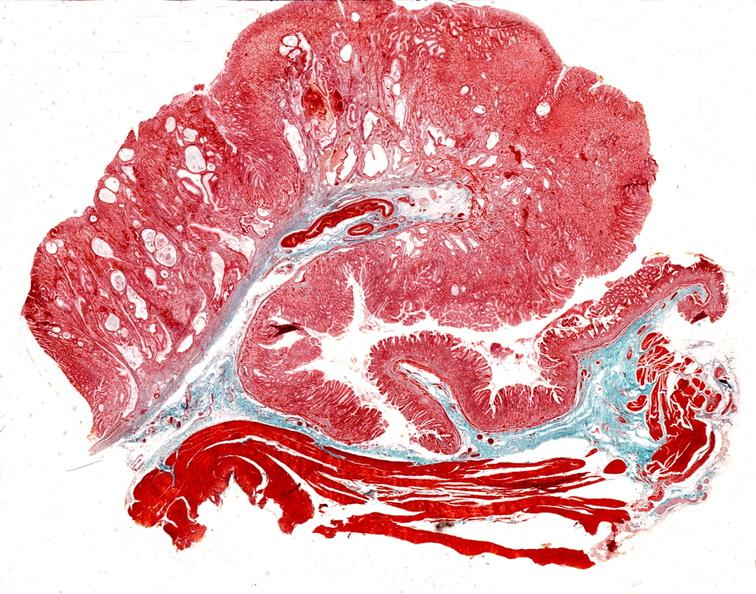does iron show stomach, giant rugose hyperplasia?
Answer the question using a single word or phrase. No 